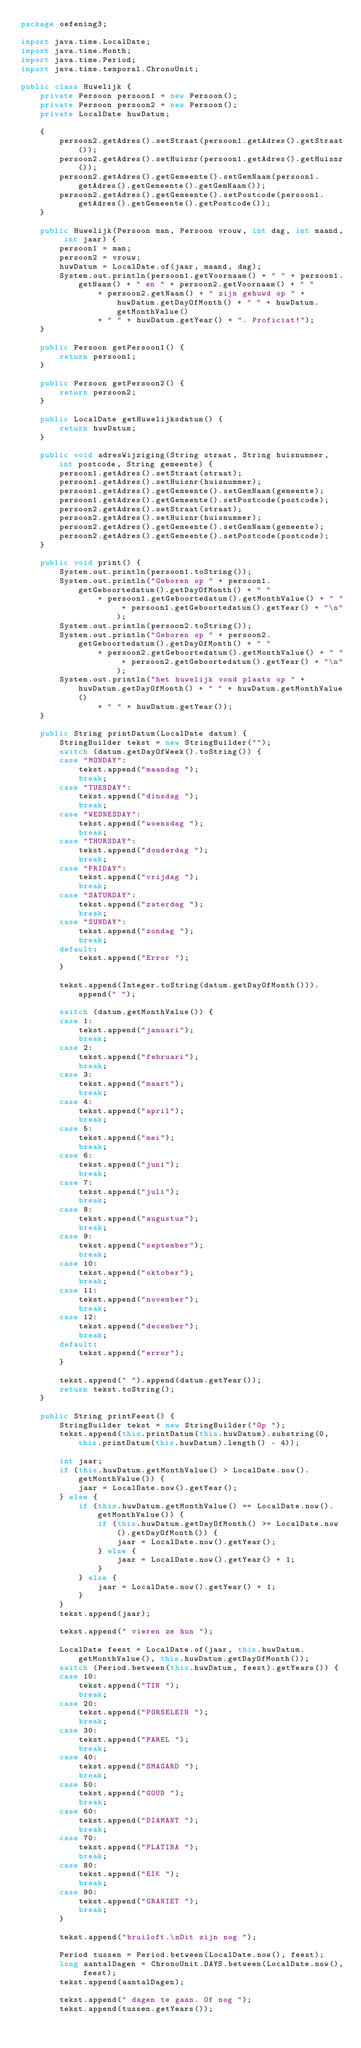<code> <loc_0><loc_0><loc_500><loc_500><_Java_>package oefening3;

import java.time.LocalDate;
import java.time.Month;
import java.time.Period;
import java.time.temporal.ChronoUnit;

public class Huwelijk {
	private Persoon persoon1 = new Persoon();
	private Persoon persoon2 = new Persoon();
	private LocalDate huwDatum;

	{
		persoon2.getAdres().setStraat(persoon1.getAdres().getStraat());
		persoon2.getAdres().setHuisnr(persoon1.getAdres().getHuisnr());
		persoon2.getAdres().getGemeente().setGemNaam(persoon1.getAdres().getGemeente().getGemNaam());
		persoon2.getAdres().getGemeente().setPostcode(persoon1.getAdres().getGemeente().getPostcode());
	}

	public Huwelijk(Persoon man, Persoon vrouw, int dag, int maand, int jaar) {
		persoon1 = man;
		persoon2 = vrouw;
		huwDatum = LocalDate.of(jaar, maand, dag);
		System.out.println(persoon1.getVoornaam() + " " + persoon1.getNaam() + " en " + persoon2.getVoornaam() + " "
				+ persoon2.getNaam() + " zijn gehuwd op " + huwDatum.getDayOfMonth() + " " + huwDatum.getMonthValue()
				+ " " + huwDatum.getYear() + ". Proficiat!");
	}

	public Persoon getPersoon1() {
		return persoon1;
	}

	public Persoon getPersoon2() {
		return persoon2;
	}

	public LocalDate getHuwelijksdatum() {
		return huwDatum;
	}

	public void adresWijziging(String straat, String huisnummer, int postcode, String gemeente) {
		persoon1.getAdres().setStraat(straat);
		persoon1.getAdres().setHuisnr(huisnummer);
		persoon1.getAdres().getGemeente().setGemNaam(gemeente);
		persoon1.getAdres().getGemeente().setPostcode(postcode);
		persoon2.getAdres().setStraat(straat);
		persoon2.getAdres().setHuisnr(huisnummer);
		persoon2.getAdres().getGemeente().setGemNaam(gemeente);
		persoon2.getAdres().getGemeente().setPostcode(postcode);
	}

	public void print() {
		System.out.println(persoon1.toString());
		System.out.println("Geboren op " + persoon1.getGeboortedatum().getDayOfMonth() + " "
				+ persoon1.getGeboortedatum().getMonthValue() + " " + persoon1.getGeboortedatum().getYear() + "\n");
		System.out.println(persoon2.toString());
		System.out.println("Geboren op " + persoon2.getGeboortedatum().getDayOfMonth() + " "
				+ persoon2.getGeboortedatum().getMonthValue() + " " + persoon2.getGeboortedatum().getYear() + "\n");
		System.out.println("het huwelijk vond plaats op " + huwDatum.getDayOfMonth() + " " + huwDatum.getMonthValue()
				+ " " + huwDatum.getYear());
	}

	public String printDatum(LocalDate datum) {
		StringBuilder tekst = new StringBuilder("");
		switch (datum.getDayOfWeek().toString()) {
		case "MONDAY":
			tekst.append("maandag ");
			break;
		case "TUESDAY":
			tekst.append("dinsdag ");
			break;
		case "WEDNESDAY":
			tekst.append("woensdag ");
			break;
		case "THURSDAY":
			tekst.append("donderdag ");
			break;
		case "FRIDAY":
			tekst.append("vrijdag ");
			break;
		case "SATURDAY":
			tekst.append("zaterdag ");
			break;
		case "SUNDAY":
			tekst.append("zondag ");
			break;
		default:
			tekst.append("Error ");
		}

		tekst.append(Integer.toString(datum.getDayOfMonth())).append(" ");

		switch (datum.getMonthValue()) {
		case 1:
			tekst.append("januari");
			break;
		case 2:
			tekst.append("februari");
			break;
		case 3:
			tekst.append("maart");
			break;
		case 4:
			tekst.append("april");
			break;
		case 5:
			tekst.append("mei");
			break;
		case 6:
			tekst.append("juni");
			break;
		case 7:
			tekst.append("juli");
			break;
		case 8:
			tekst.append("augustus");
			break;
		case 9:
			tekst.append("september");
			break;
		case 10:
			tekst.append("oktober");
			break;
		case 11:
			tekst.append("november");
			break;
		case 12:
			tekst.append("december");
			break;
		default:
			tekst.append("error");
		}

		tekst.append(" ").append(datum.getYear());
		return tekst.toString();
	}

	public String printFeest() {
		StringBuilder tekst = new StringBuilder("Op ");
		tekst.append(this.printDatum(this.huwDatum).substring(0, this.printDatum(this.huwDatum).length() - 4));

		int jaar;
		if (this.huwDatum.getMonthValue() > LocalDate.now().getMonthValue()) {
			jaar = LocalDate.now().getYear();
		} else {
			if (this.huwDatum.getMonthValue() == LocalDate.now().getMonthValue()) {
				if (this.huwDatum.getDayOfMonth() >= LocalDate.now().getDayOfMonth()) {
					jaar = LocalDate.now().getYear();
				} else {
					jaar = LocalDate.now().getYear() + 1;
				}
			} else {
				jaar = LocalDate.now().getYear() + 1;
			}
		}
		tekst.append(jaar);

		tekst.append(" vieren ze hun ");

		LocalDate feest = LocalDate.of(jaar, this.huwDatum.getMonthValue(), this.huwDatum.getDayOfMonth());
		switch (Period.between(this.huwDatum, feest).getYears()) {
		case 10:
			tekst.append("TIN ");
			break;
		case 20:
			tekst.append("PORSELEIN ");
			break;
		case 30:
			tekst.append("PAREL ");
			break;
		case 40:
			tekst.append("SMAGARD ");
			break;
		case 50:
			tekst.append("GOUD ");
			break;
		case 60:
			tekst.append("DIAMANT ");
			break;
		case 70:
			tekst.append("PLATINA ");
			break;
		case 80:
			tekst.append("EIK ");
			break;
		case 90:
			tekst.append("GRANIET ");
			break;
		}

		tekst.append("bruiloft.\nDit zijn nog ");

		Period tussen = Period.between(LocalDate.now(), feest);
		long aantalDagen = ChronoUnit.DAYS.between(LocalDate.now(), feest);
		tekst.append(aantalDagen);

		tekst.append(" dagen te gaan. Of nog ");
		tekst.append(tussen.getYears());</code> 